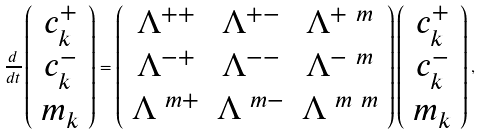Convert formula to latex. <formula><loc_0><loc_0><loc_500><loc_500>\frac { d } { d t } \left ( \begin{array} { c } c ^ { + } _ { k } \\ c ^ { - } _ { k } \\ m _ { k } \end{array} \right ) = \left ( \begin{array} { c c c } \Lambda ^ { + + } & \Lambda ^ { + - } & \Lambda ^ { + \ m } \\ \Lambda ^ { - + } & \Lambda ^ { - - } & \Lambda ^ { - \ m } \\ \Lambda ^ { \ m + } & \Lambda ^ { \ m - } & \Lambda ^ { \ m \ m } \end{array} \right ) \left ( \begin{array} { c } c ^ { + } _ { k } \\ c ^ { - } _ { k } \\ m _ { k } \end{array} \right ) ,</formula> 